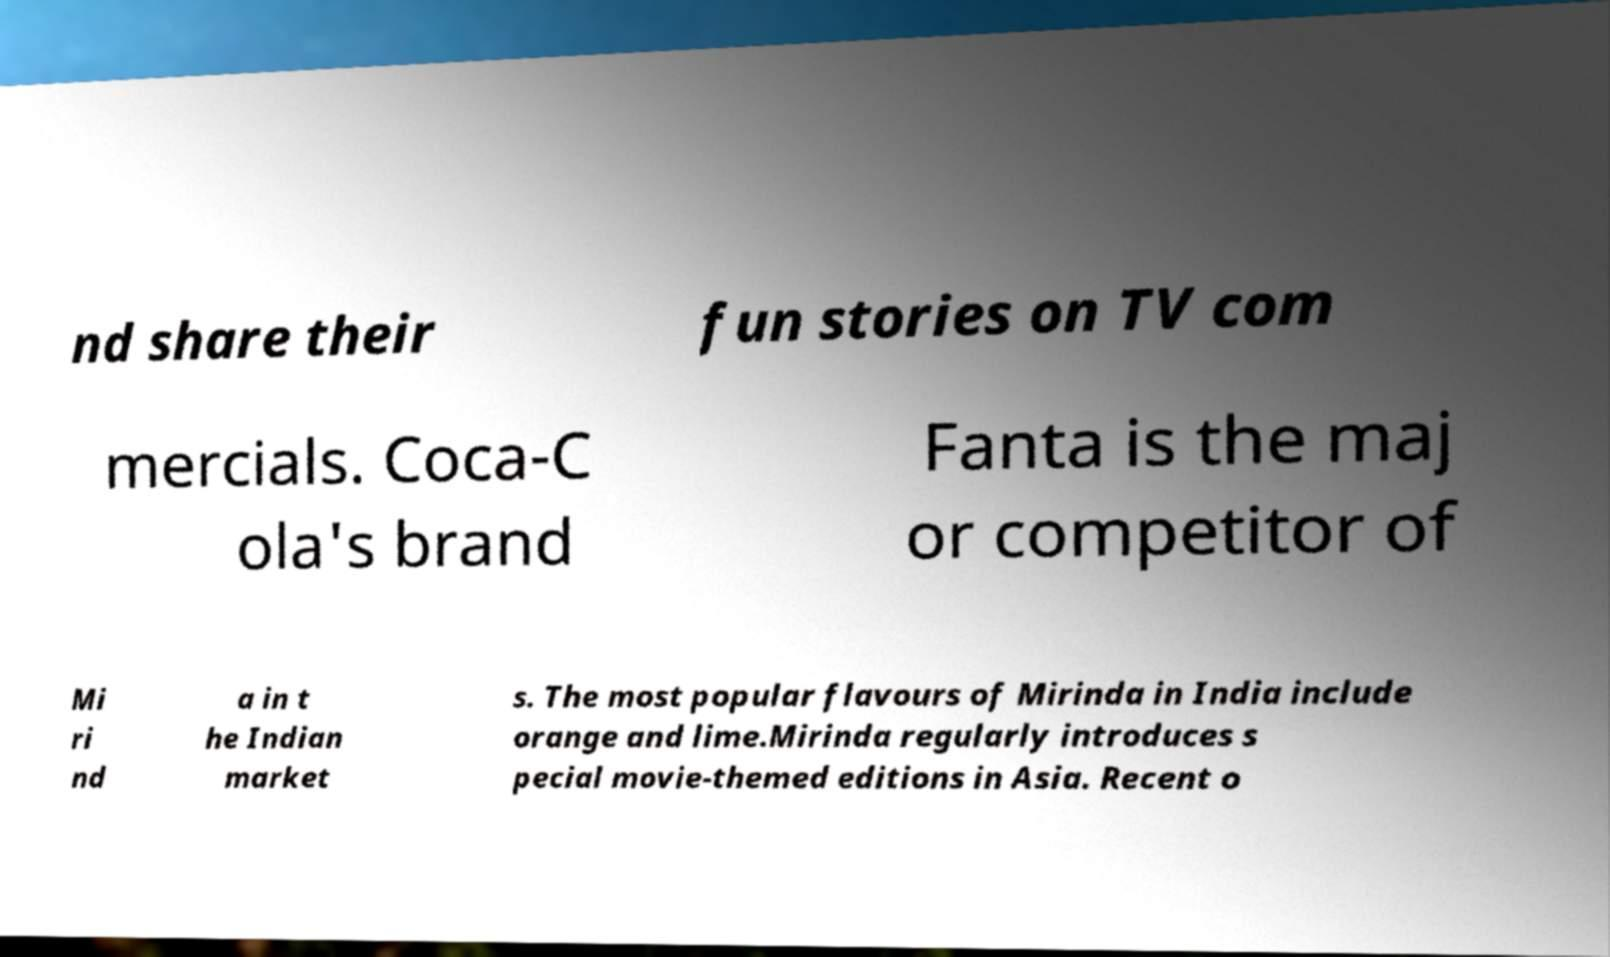What messages or text are displayed in this image? I need them in a readable, typed format. nd share their fun stories on TV com mercials. Coca-C ola's brand Fanta is the maj or competitor of Mi ri nd a in t he Indian market s. The most popular flavours of Mirinda in India include orange and lime.Mirinda regularly introduces s pecial movie-themed editions in Asia. Recent o 